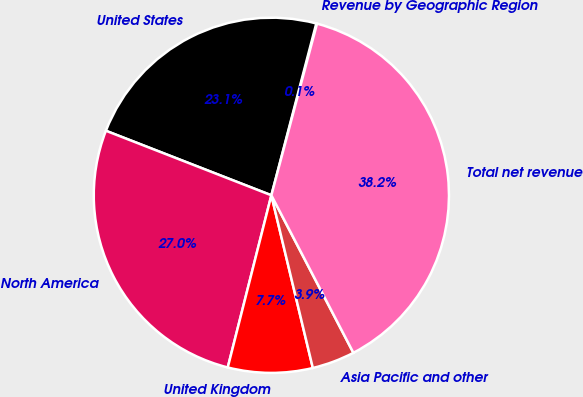<chart> <loc_0><loc_0><loc_500><loc_500><pie_chart><fcel>Revenue by Geographic Region<fcel>United States<fcel>North America<fcel>United Kingdom<fcel>Asia Pacific and other<fcel>Total net revenue<nl><fcel>0.07%<fcel>23.15%<fcel>26.97%<fcel>7.7%<fcel>3.89%<fcel>38.22%<nl></chart> 